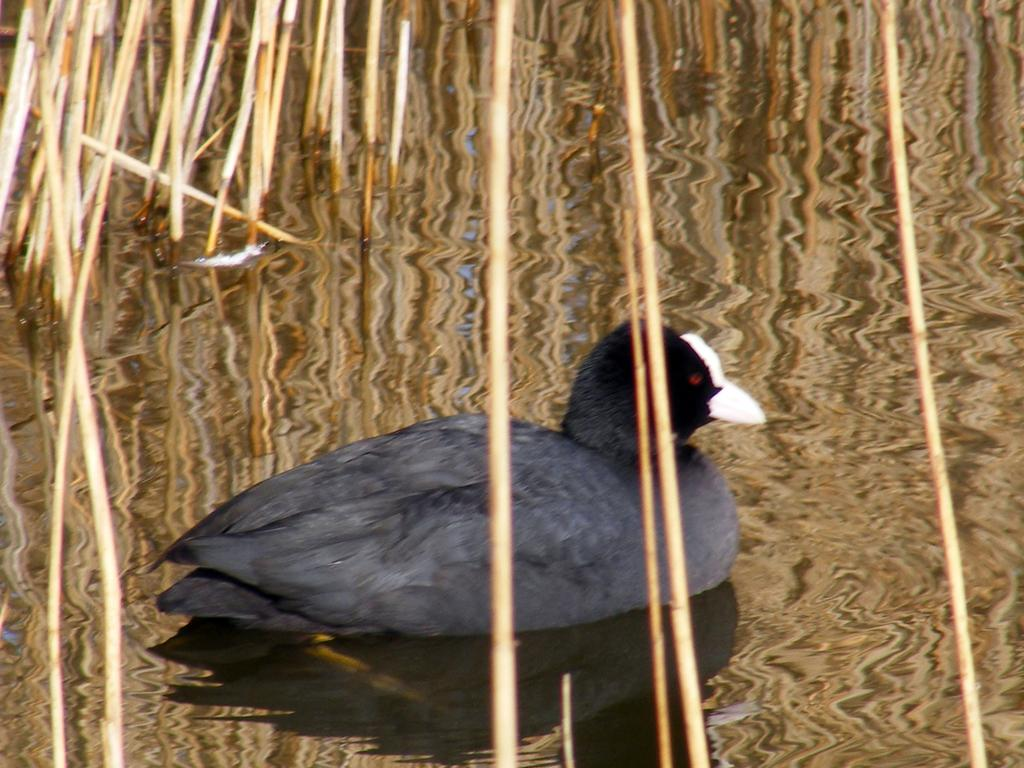What is present in the image? There is water in the image. What can be found within the water? There are weed plants in the water. Are there any animals visible in the image? Yes, there is a duck in the water. What type of range can be seen in the image? There is no range present in the image; it features water with weed plants and a duck. Are there any giants visible in the image? There are no giants present in the image. 